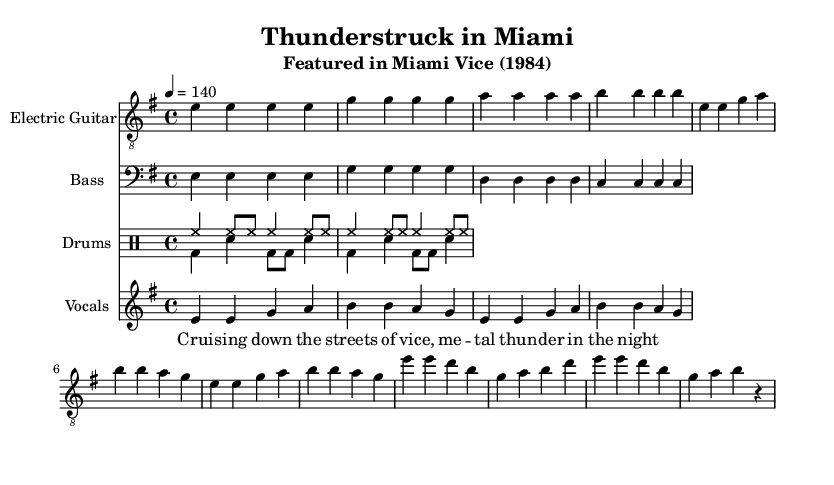What is the key signature of this music? The key signature is indicated by the sharps or flats in the left-hand corner of the music sheet. In this case, the absence of any sharps or flats indicates it is in E minor, which corresponds to one sharp in its relative major, G major.
Answer: E minor What is the time signature of this piece? The time signature is located at the beginning of the music notation, indicating how many beats are in each measure. Here, the time signature is shown as 4/4, meaning there are four beats in each measure.
Answer: 4/4 What is the tempo of the song? The tempo is typically indicated above the staff, often with a metronome marking. In this case, the tempo marking is set to 140 beats per minute, meaning the music should be played quite briskly.
Answer: 140 Which instrument is playing the bass line? The bass line is written on the staff that has the bass clef, indicating it is intended for a bass instrument. Here, it specifically states "Bass" in the staff header, confirming it is the bass guitar playing this part.
Answer: Bass guitar How many measures are in the chorus section? To determine the number of measures, count the segments between vertical lines in the chorus section of the sheet music, where the chorus begins after the verse. The chorus contains a total of four measures as separated by these lines.
Answer: Four What kind of vocal style is represented in the lyrics section? The lyrics are written to accompany the melody with specific syllables assigned to musical notes. Here, the vocal line appears to have a metal style indicated by the assertive phrasing in the lyrics "Crui -- sing down the streets of vice," a characteristic often found in metal music.
Answer: Metal 